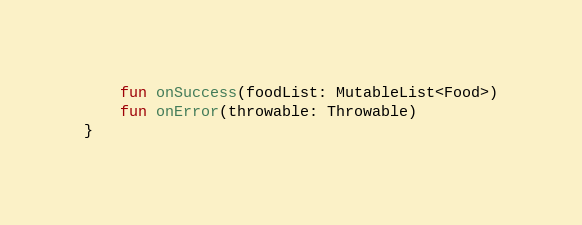<code> <loc_0><loc_0><loc_500><loc_500><_Kotlin_>    fun onSuccess(foodList: MutableList<Food>)
    fun onError(throwable: Throwable)
}</code> 